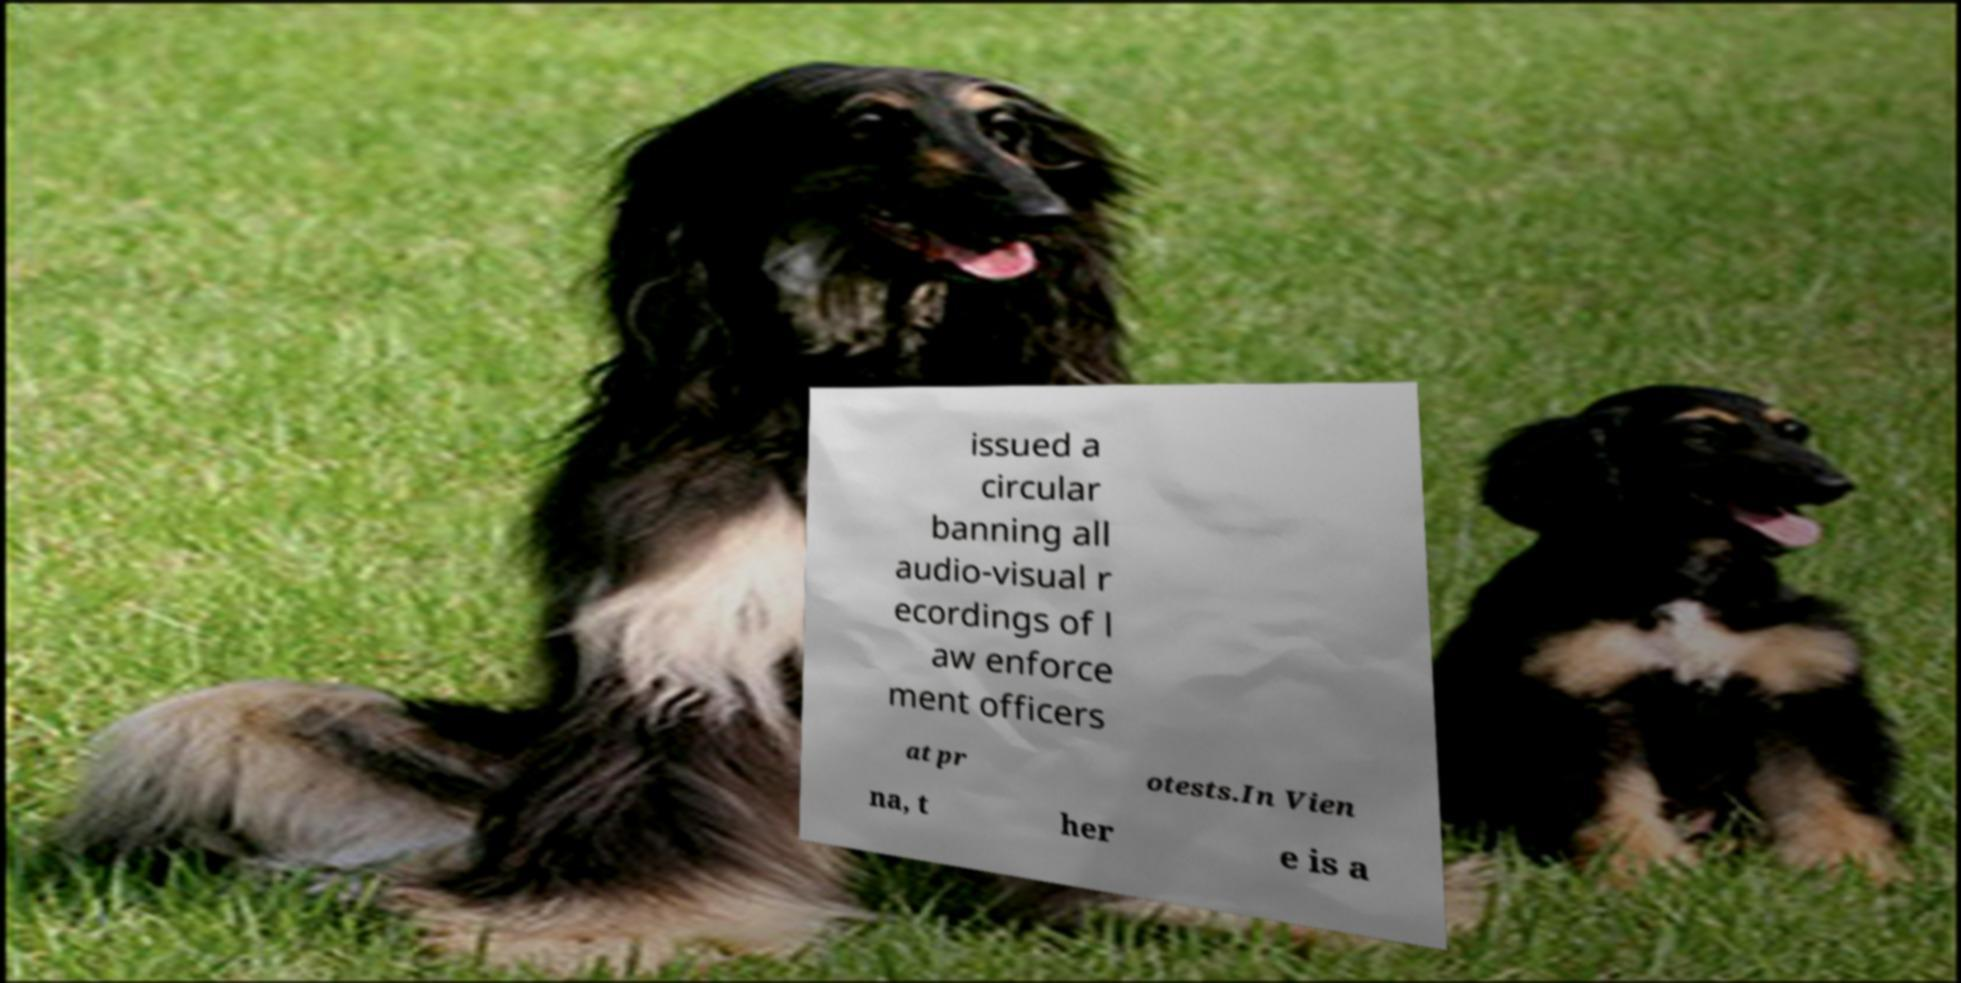Could you extract and type out the text from this image? issued a circular banning all audio-visual r ecordings of l aw enforce ment officers at pr otests.In Vien na, t her e is a 